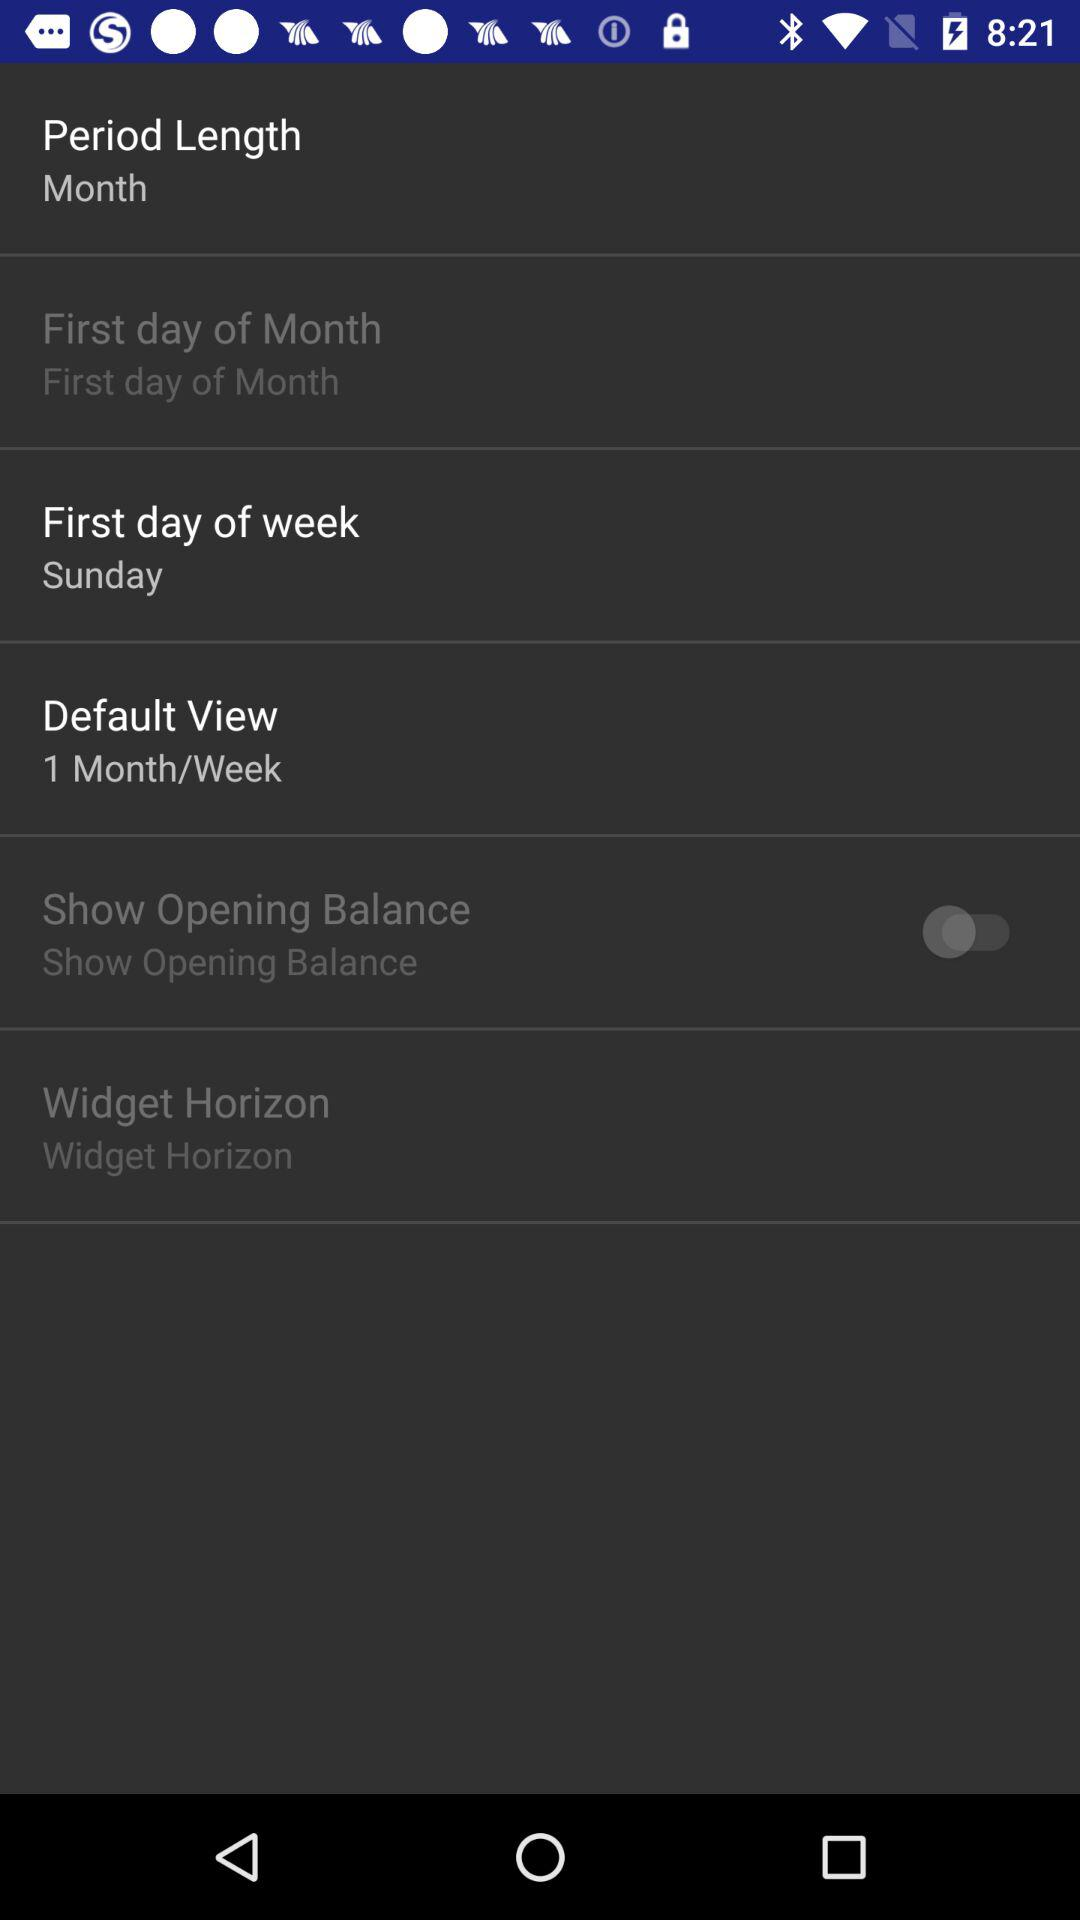Is "Widget Horizon" checked or unchecked?
When the provided information is insufficient, respond with <no answer>. <no answer> 